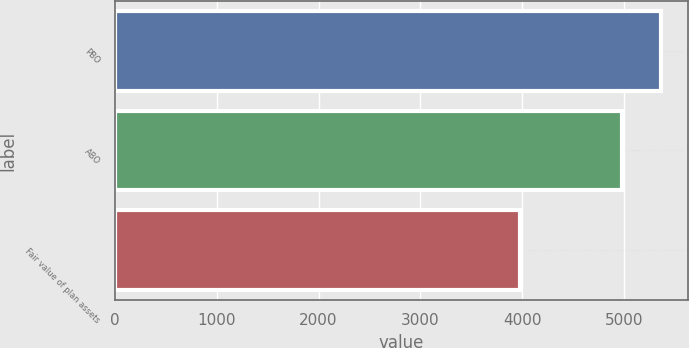Convert chart. <chart><loc_0><loc_0><loc_500><loc_500><bar_chart><fcel>PBO<fcel>ABO<fcel>Fair value of plan assets<nl><fcel>5360.2<fcel>4980.5<fcel>3977.8<nl></chart> 